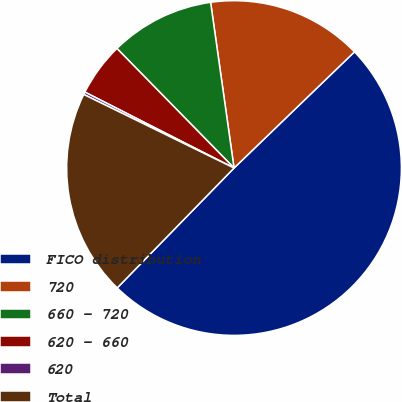<chart> <loc_0><loc_0><loc_500><loc_500><pie_chart><fcel>FICO distribution<fcel>720<fcel>660 - 720<fcel>620 - 660<fcel>620<fcel>Total<nl><fcel>49.51%<fcel>15.02%<fcel>10.1%<fcel>5.17%<fcel>0.25%<fcel>19.95%<nl></chart> 